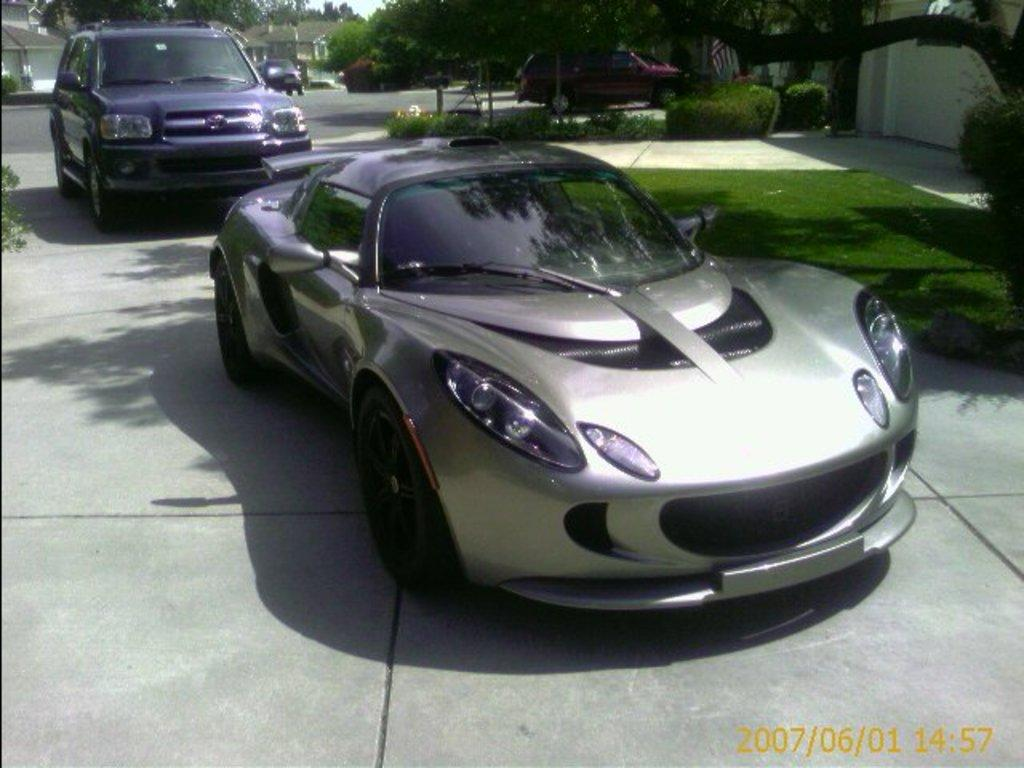What types of objects are on the ground in the image? There are vehicles on the ground in the image. What can be seen in the background of the image? There are trees, grass, buildings, the sky, and plants visible in the background of the image. Are there any other objects on the ground in the background of the image? Yes, there are other objects on the ground in the background of the image. What type of creature is responsible for the surprise in the image? There is no creature or surprise present in the image. 